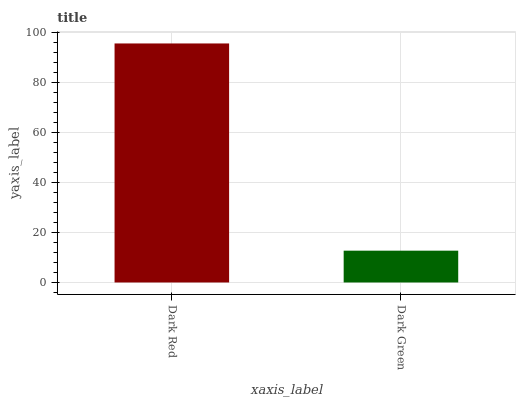Is Dark Green the maximum?
Answer yes or no. No. Is Dark Red greater than Dark Green?
Answer yes or no. Yes. Is Dark Green less than Dark Red?
Answer yes or no. Yes. Is Dark Green greater than Dark Red?
Answer yes or no. No. Is Dark Red less than Dark Green?
Answer yes or no. No. Is Dark Red the high median?
Answer yes or no. Yes. Is Dark Green the low median?
Answer yes or no. Yes. Is Dark Green the high median?
Answer yes or no. No. Is Dark Red the low median?
Answer yes or no. No. 